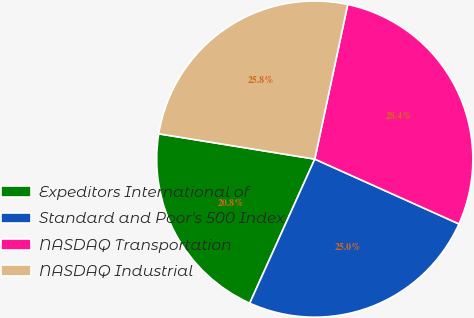Convert chart to OTSL. <chart><loc_0><loc_0><loc_500><loc_500><pie_chart><fcel>Expeditors International of<fcel>Standard and Poor's 500 Index<fcel>NASDAQ Transportation<fcel>NASDAQ Industrial<nl><fcel>20.81%<fcel>25.02%<fcel>28.38%<fcel>25.78%<nl></chart> 